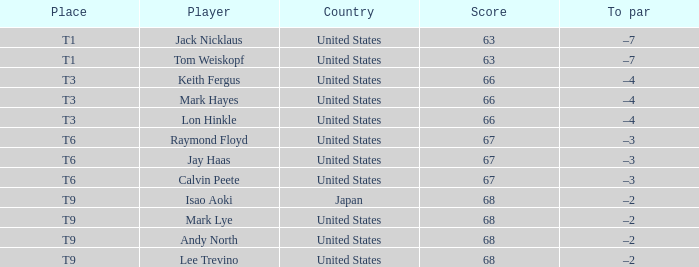What is Place, when Country is "United States", and when Player is "Lee Trevino"? T9. 